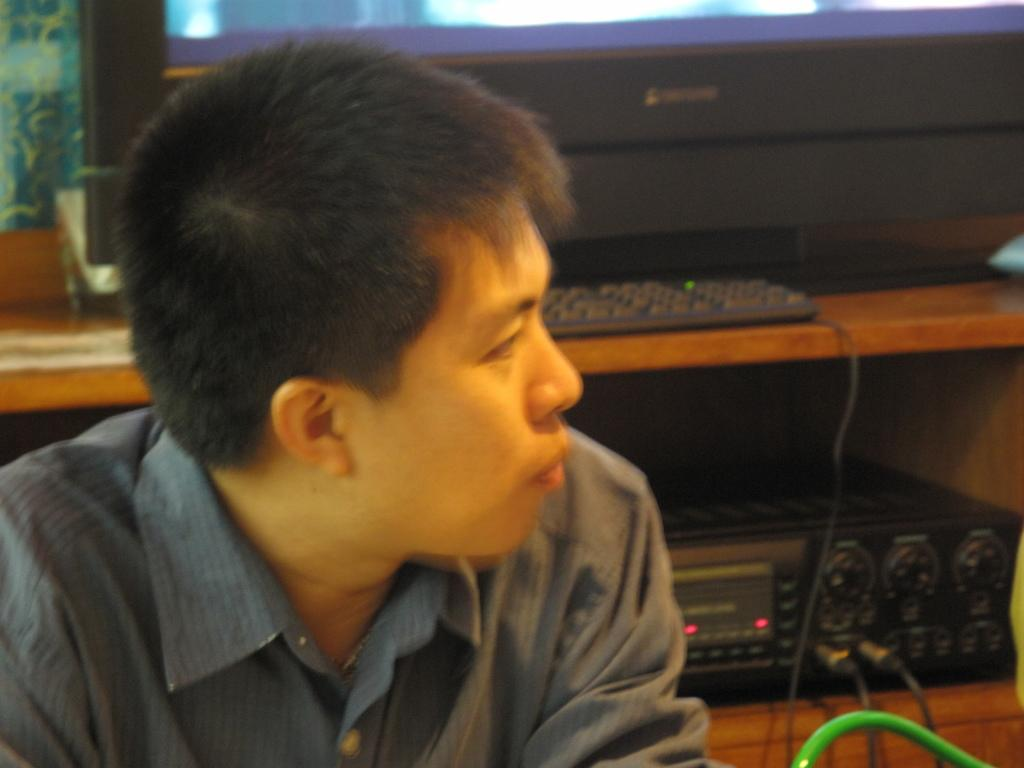Who is present in the image? There is a man in the image. What direction is the man looking in? The man is looking to his left. What objects can be seen in the image? There is a keyboard and a sound box in the image. What is the man thinking about in the image? The image does not provide any information about the man's thoughts, so we cannot determine what he might be thinking about. 